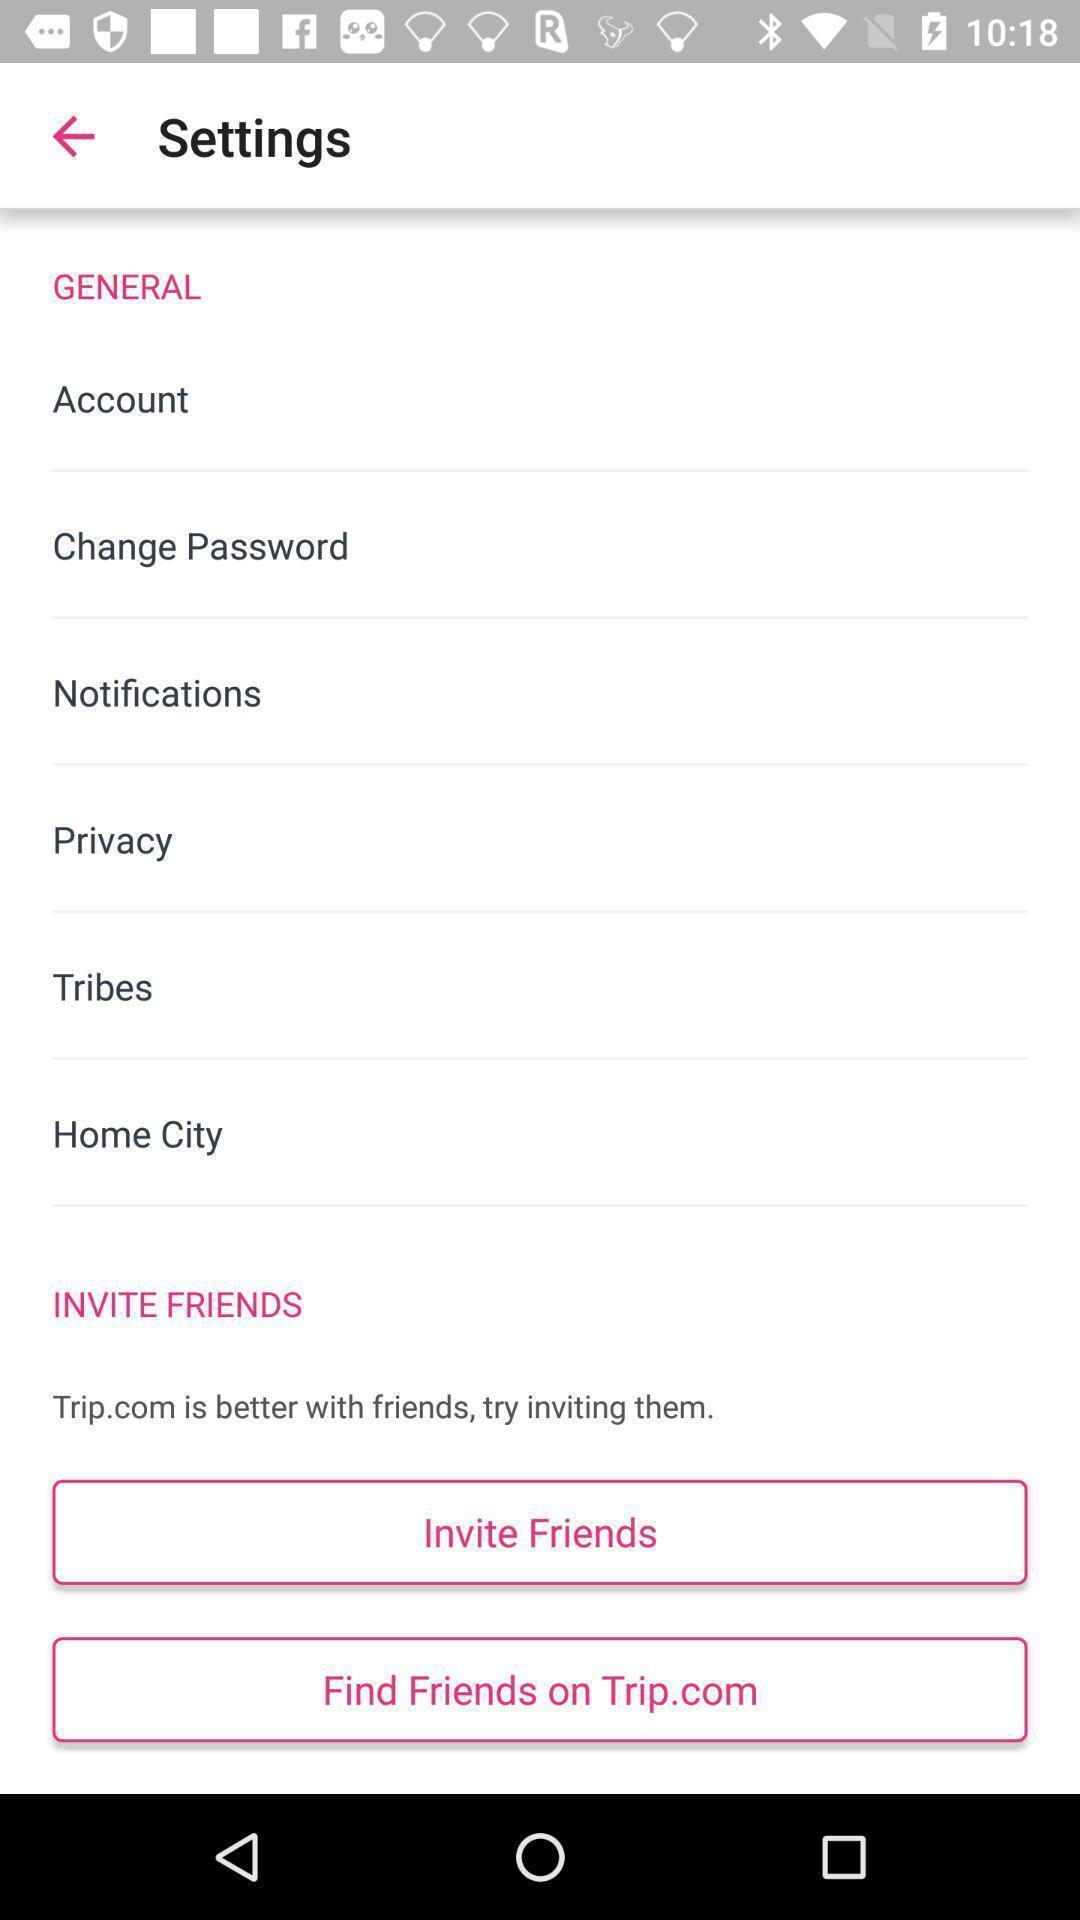Give me a summary of this screen capture. Settings page. 